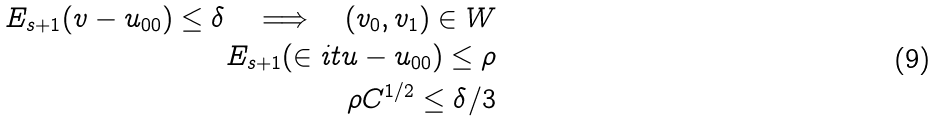<formula> <loc_0><loc_0><loc_500><loc_500>E _ { s + 1 } ( v - u _ { 0 0 } ) \leq \delta \quad \Longrightarrow \quad ( v _ { 0 } , v _ { 1 } ) \in W \\ E _ { s + 1 } ( \in i t { u } - u _ { 0 0 } ) \leq \rho \\ \rho C ^ { 1 / 2 } \leq \delta / 3</formula> 